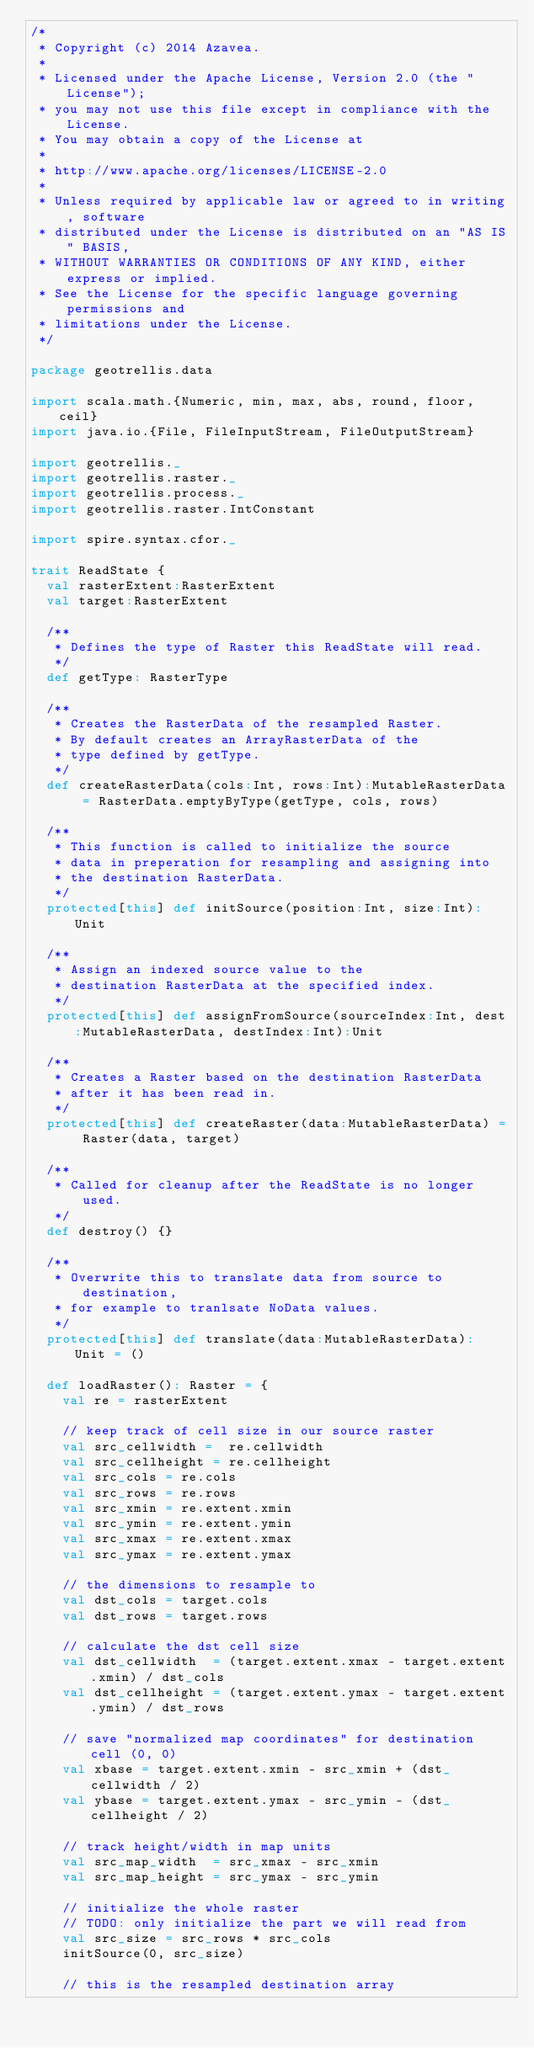Convert code to text. <code><loc_0><loc_0><loc_500><loc_500><_Scala_>/*
 * Copyright (c) 2014 Azavea.
 * 
 * Licensed under the Apache License, Version 2.0 (the "License");
 * you may not use this file except in compliance with the License.
 * You may obtain a copy of the License at
 * 
 * http://www.apache.org/licenses/LICENSE-2.0
 * 
 * Unless required by applicable law or agreed to in writing, software
 * distributed under the License is distributed on an "AS IS" BASIS,
 * WITHOUT WARRANTIES OR CONDITIONS OF ANY KIND, either express or implied.
 * See the License for the specific language governing permissions and
 * limitations under the License.
 */

package geotrellis.data

import scala.math.{Numeric, min, max, abs, round, floor, ceil}
import java.io.{File, FileInputStream, FileOutputStream}

import geotrellis._
import geotrellis.raster._
import geotrellis.process._
import geotrellis.raster.IntConstant

import spire.syntax.cfor._

trait ReadState {
  val rasterExtent:RasterExtent
  val target:RasterExtent

  /**
   * Defines the type of Raster this ReadState will read.
   */
  def getType: RasterType

  /**
   * Creates the RasterData of the resampled Raster.
   * By default creates an ArrayRasterData of the 
   * type defined by getType.
   */
  def createRasterData(cols:Int, rows:Int):MutableRasterData = RasterData.emptyByType(getType, cols, rows)

  /**
   * This function is called to initialize the source
   * data in preperation for resampling and assigning into
   * the destination RasterData.
   */
  protected[this] def initSource(position:Int, size:Int):Unit

  /**
   * Assign an indexed source value to the
   * destination RasterData at the specified index.
   */
  protected[this] def assignFromSource(sourceIndex:Int, dest:MutableRasterData, destIndex:Int):Unit

  /**
   * Creates a Raster based on the destination RasterData
   * after it has been read in.
   */
  protected[this] def createRaster(data:MutableRasterData) = Raster(data, target)

  /**
   * Called for cleanup after the ReadState is no longer used.
   */
  def destroy() {}

  /**
   * Overwrite this to translate data from source to destination,
   * for example to tranlsate NoData values.
   */
  protected[this] def translate(data:MutableRasterData): Unit = ()

  def loadRaster(): Raster = {
    val re = rasterExtent

    // keep track of cell size in our source raster
    val src_cellwidth =  re.cellwidth
    val src_cellheight = re.cellheight
    val src_cols = re.cols
    val src_rows = re.rows
    val src_xmin = re.extent.xmin
    val src_ymin = re.extent.ymin
    val src_xmax = re.extent.xmax
    val src_ymax = re.extent.ymax

    // the dimensions to resample to
    val dst_cols = target.cols
    val dst_rows = target.rows

    // calculate the dst cell size
    val dst_cellwidth  = (target.extent.xmax - target.extent.xmin) / dst_cols
    val dst_cellheight = (target.extent.ymax - target.extent.ymin) / dst_rows

    // save "normalized map coordinates" for destination cell (0, 0)
    val xbase = target.extent.xmin - src_xmin + (dst_cellwidth / 2)
    val ybase = target.extent.ymax - src_ymin - (dst_cellheight / 2)

    // track height/width in map units
    val src_map_width  = src_xmax - src_xmin
    val src_map_height = src_ymax - src_ymin

    // initialize the whole raster
    // TODO: only initialize the part we will read from
    val src_size = src_rows * src_cols
    initSource(0, src_size)
    
    // this is the resampled destination array</code> 